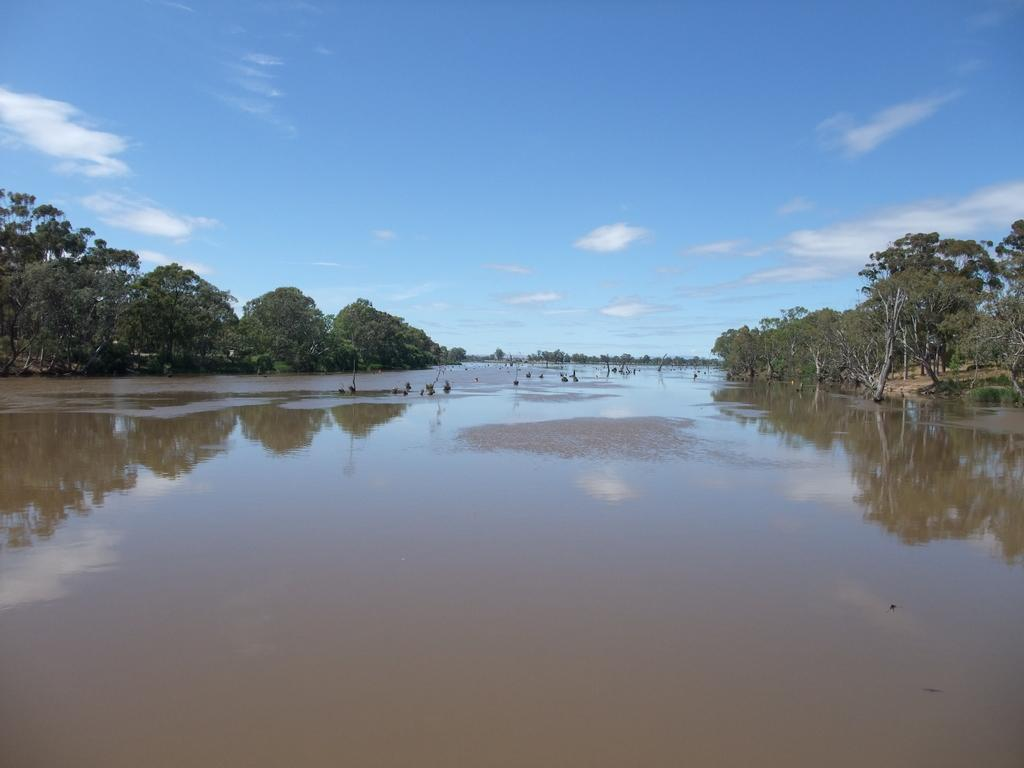What is the main feature in the center of the image? There is a river in the center of the image. What can be seen on the left side of the image? There are trees on the left side of the image. What is present on the right side of the image? There are trees on the right side of the image. What is visible at the top of the image? The sky is visible at the top of the image. How many dimes can be seen floating on the river in the image? There are no dimes visible in the image; it features a river, trees, and the sky. What type of snail is crawling on the tree on the left side of the image? There is no snail present on the tree in the image. 